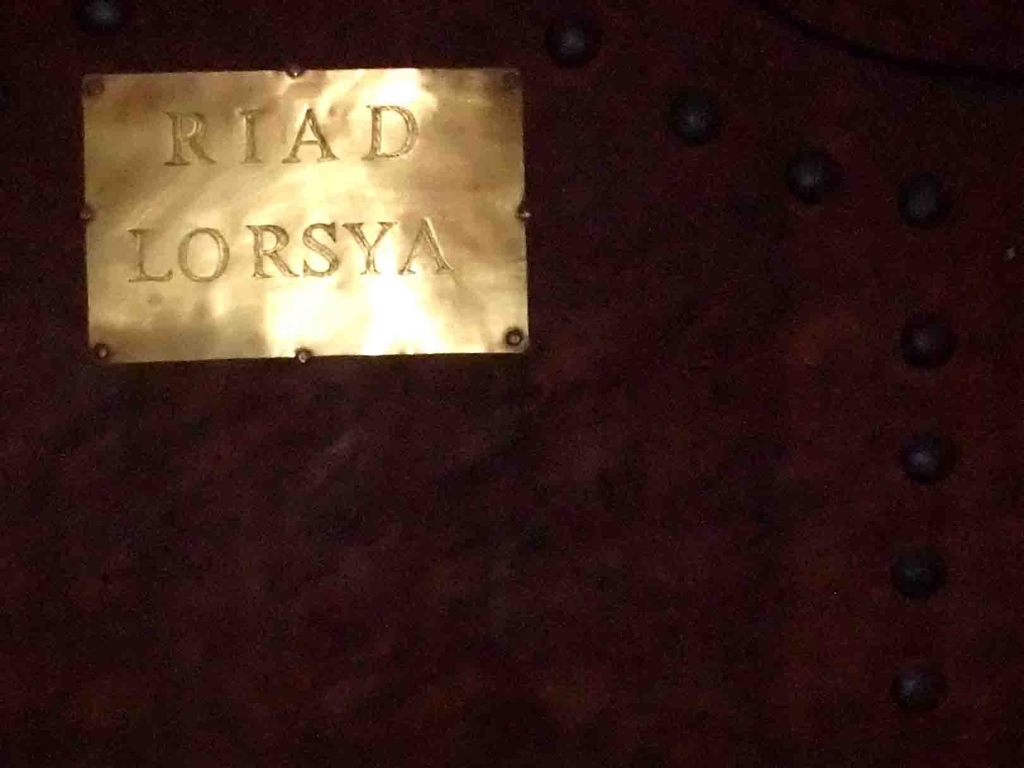How is the text on the signboard? The text on the signboard appears to be somewhat clear but is difficult to read due to the low lighting and glare affecting the visibility of the lettering. It reads 'RIAD LORSYA,' which suggests it could be the name of a place, possibly a guesthouse or hotel. 